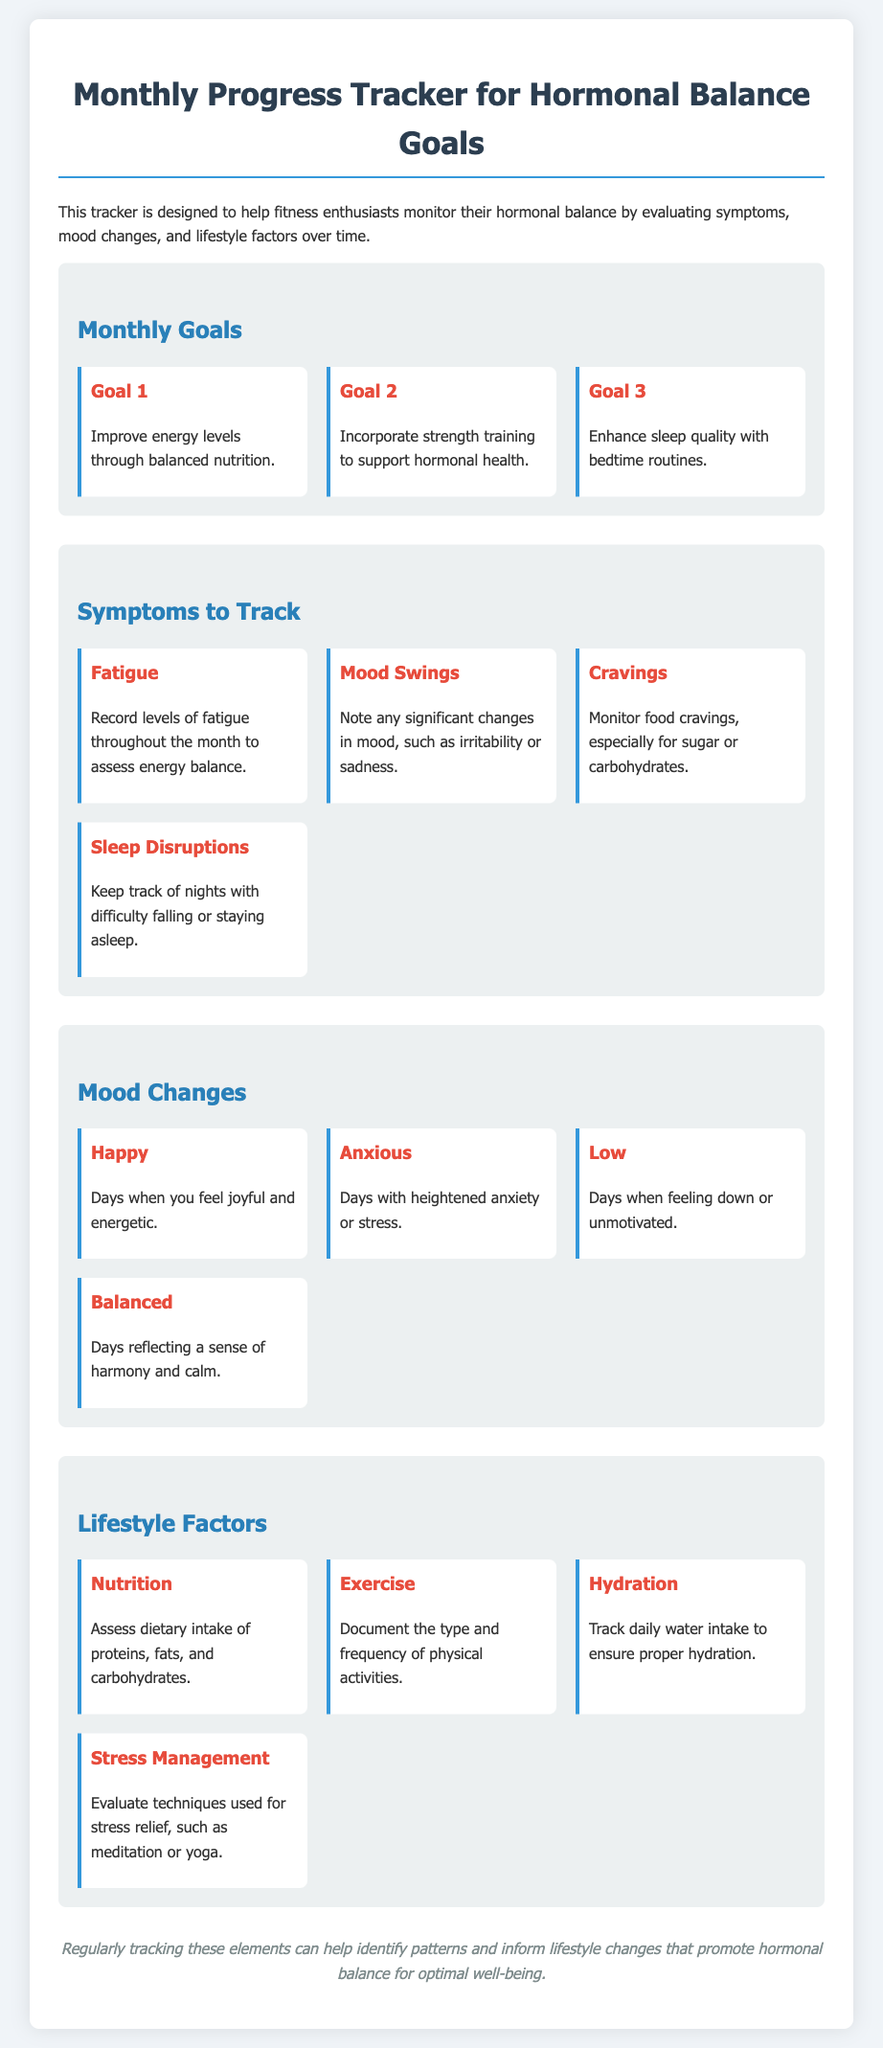What is the main purpose of the tracker? The purpose of the tracker is to help fitness enthusiasts monitor their hormonal balance by evaluating symptoms, mood changes, and lifestyle factors over time.
Answer: Monitor hormonal balance How many monthly goals are listed? The document lists three specific monthly goals under the "Monthly Goals" section.
Answer: Three What symptom should be recorded to assess energy balance? The symptom that should be recorded to assess energy balance is fatigue.
Answer: Fatigue Which mood reflects a sense of harmony and calm? The mood that reflects a sense of harmony and calm is balanced.
Answer: Balanced What lifestyle factor involves evaluating stress relief techniques? The lifestyle factor that involves evaluating stress relief techniques is stress management.
Answer: Stress Management How many symptoms are included in the tracker? There are four symptoms included in the "Symptoms to Track" section.
Answer: Four What is the first monthly goal listed? The first monthly goal listed is to improve energy levels through balanced nutrition.
Answer: Improve energy levels through balanced nutrition On what aspect does the tracker help identify patterns? The tracker helps identify patterns in hormonal balance that inform lifestyle changes.
Answer: Hormonal balance What type of activities should be documented under exercise? The tracker suggests documenting the type and frequency of physical activities.
Answer: Type and frequency of physical activities 